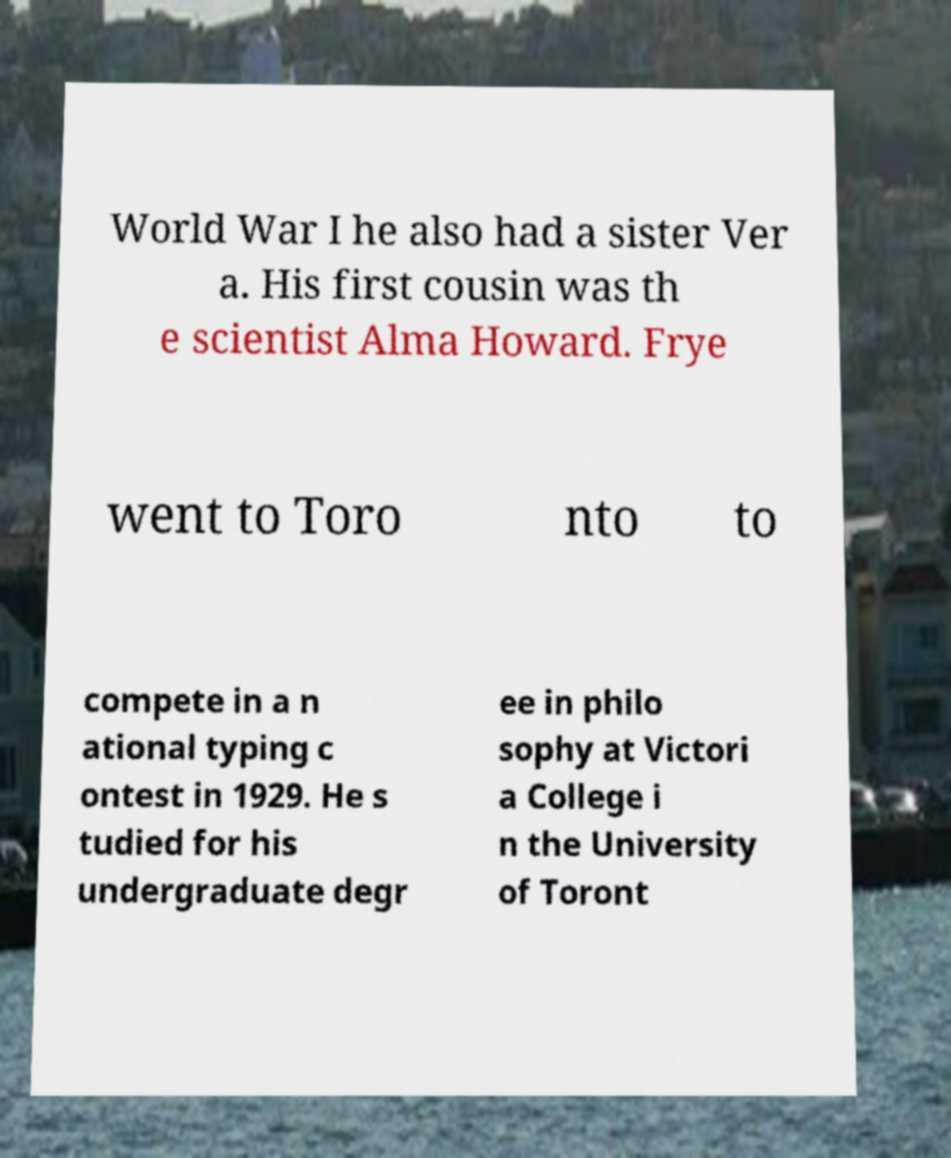Please read and relay the text visible in this image. What does it say? World War I he also had a sister Ver a. His first cousin was th e scientist Alma Howard. Frye went to Toro nto to compete in a n ational typing c ontest in 1929. He s tudied for his undergraduate degr ee in philo sophy at Victori a College i n the University of Toront 